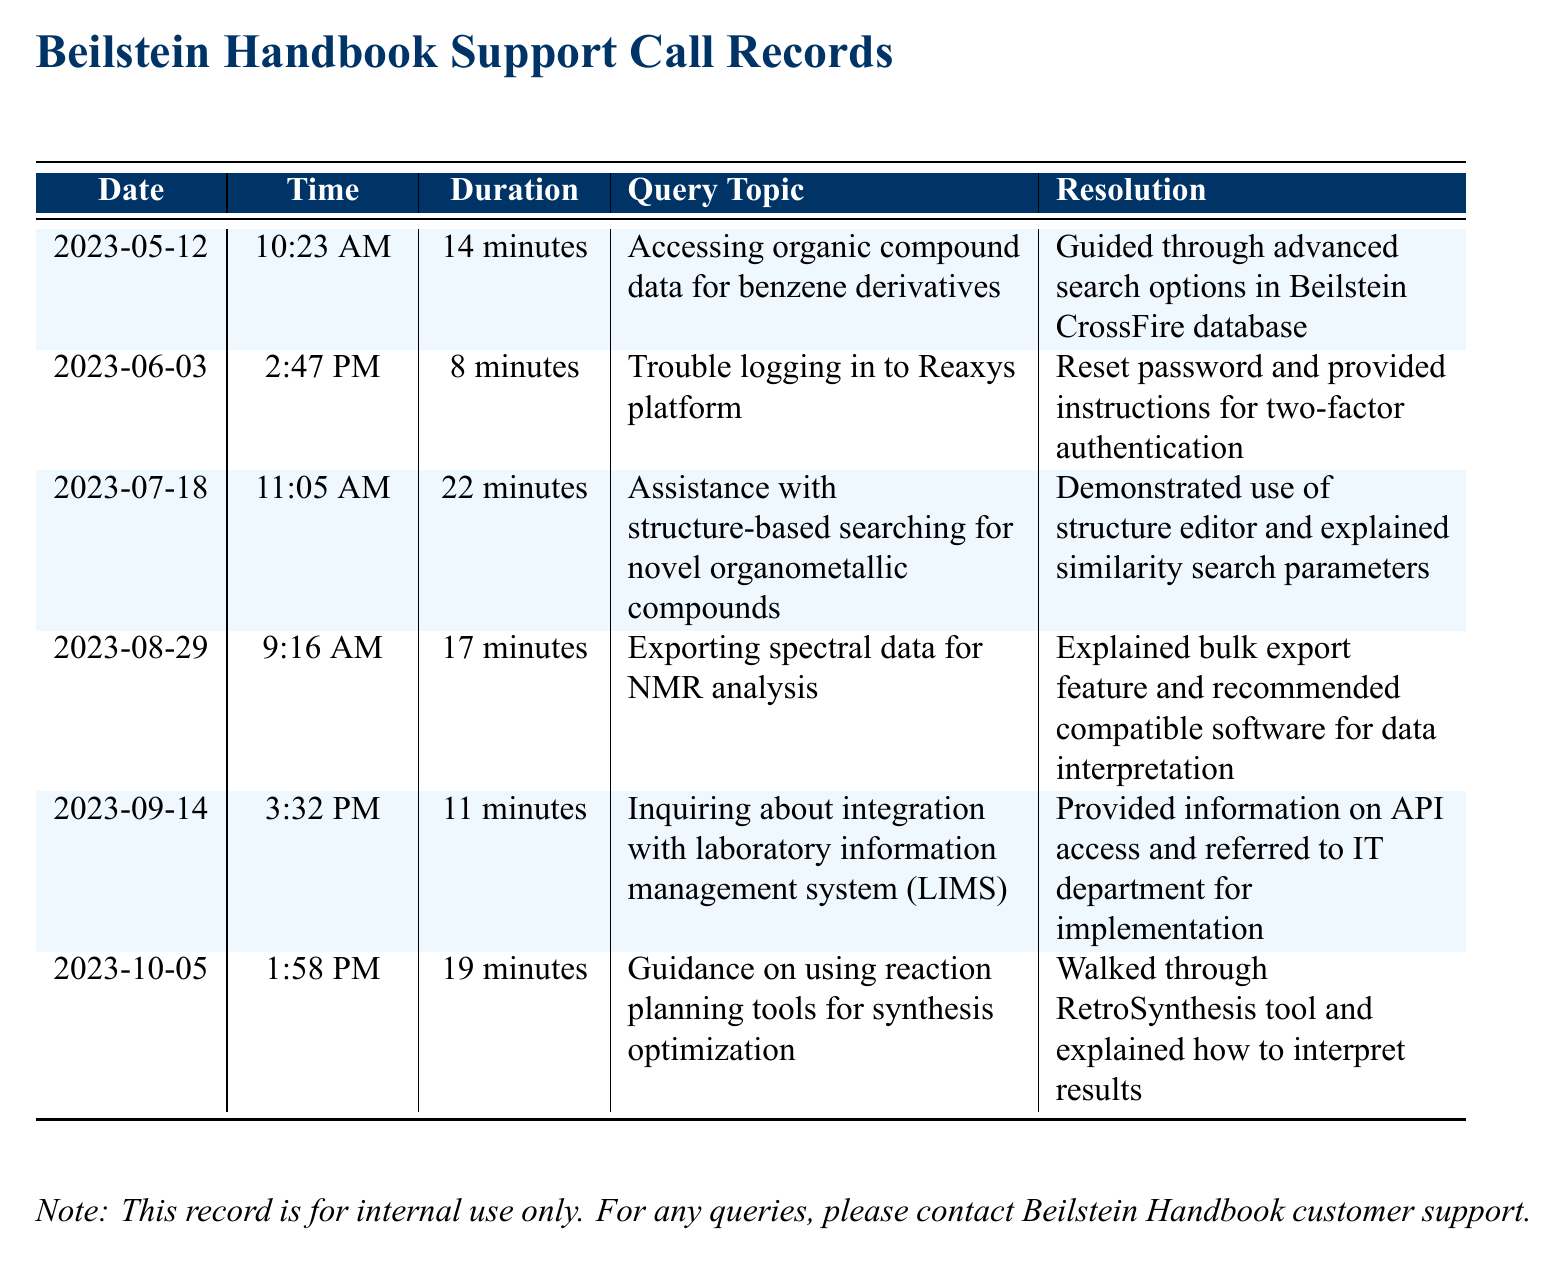what day was the call about benzene derivatives? The call regarding benzene derivatives was made on May 12, 2023.
Answer: May 12, 2023 how long was the call on structure-based searching? The duration of the call on structure-based searching was noted in the document as 22 minutes.
Answer: 22 minutes what was the main topic of the call on October 5, 2023? The main topic of the call on October 5, 2023, was guidance on using reaction planning tools for synthesis optimization.
Answer: Guidance on using reaction planning tools for synthesis optimization which feature was explained for exporting spectral data? The document indicates that the bulk export feature was explained during the call about exporting spectral data.
Answer: Bulk export feature how many calls were made in total? The document lists a total of 5 calls made to customer support.
Answer: 5 calls which resolution was provided for trouble logging into Reaxys? For the trouble logging into Reaxys, the resolution involved resetting the password and providing instructions for two-factor authentication.
Answer: Reset password and provided instructions for two-factor authentication on which date was information about API access provided? Information on API access was provided during a call on September 14, 2023.
Answer: September 14, 2023 what is the duration of the call regarding NMR analysis? The duration of the call regarding NMR analysis was stated as 17 minutes.
Answer: 17 minutes which tool was explained for reaction planning? The RetroSynthesis tool was explained during the call about synthesis optimization.
Answer: RetroSynthesis tool 